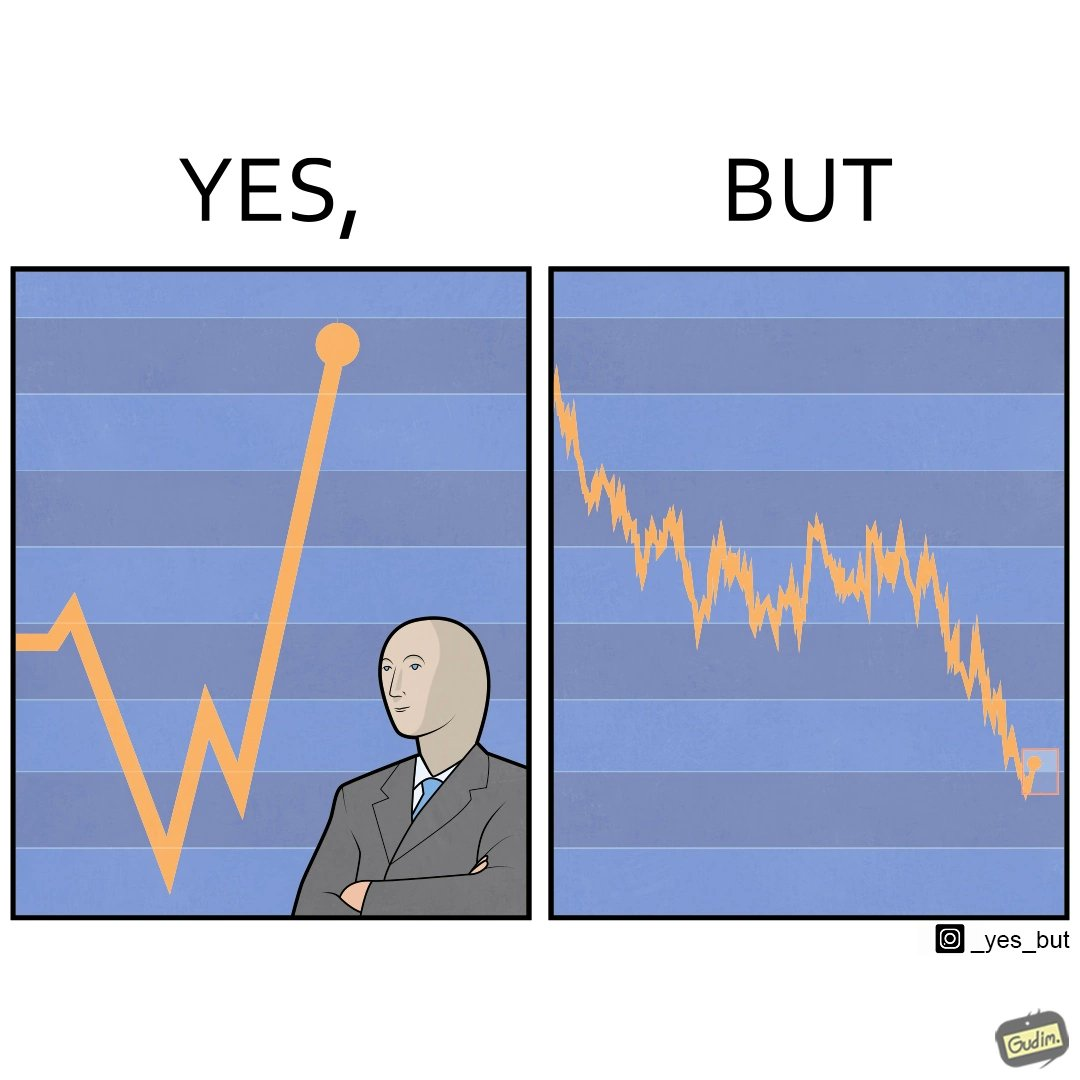What is the satirical meaning behind this image? The image is ironic, because a person is seen feeling proud over the profit earned over his investment but the right image shows the whole story how only a small part of his investment journey is shown and the other loss part is ignored 